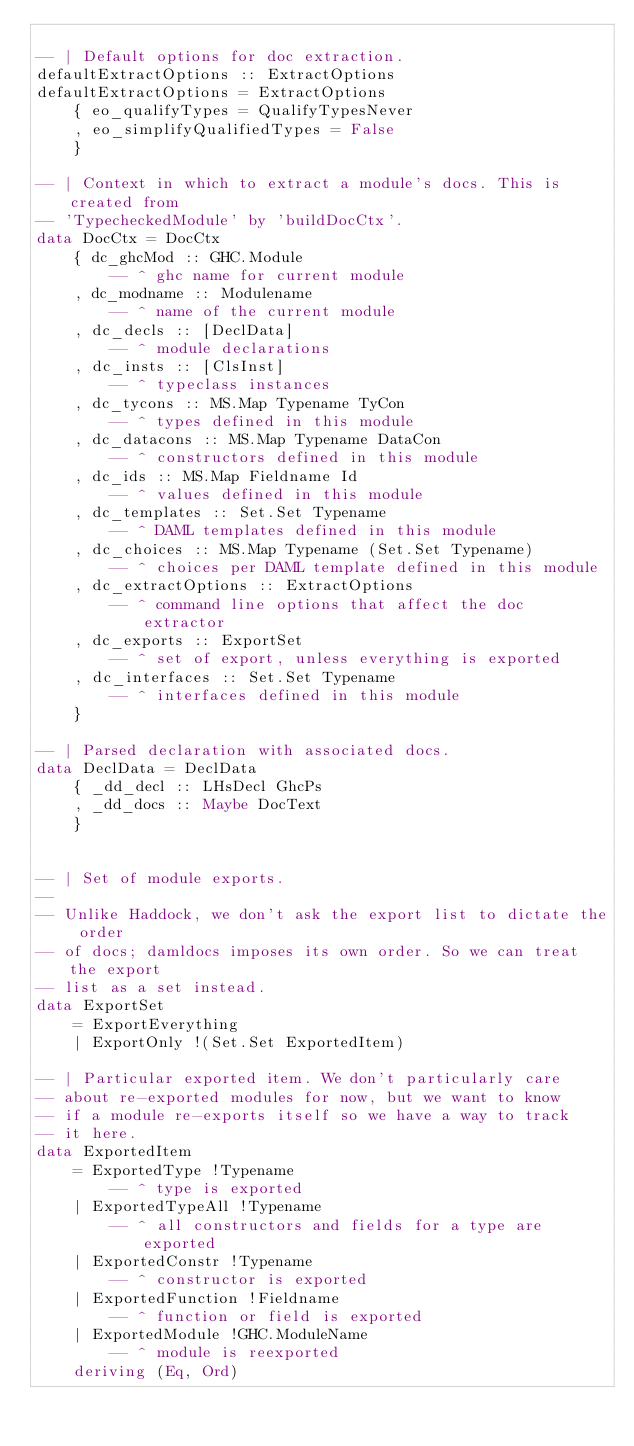Convert code to text. <code><loc_0><loc_0><loc_500><loc_500><_Haskell_>
-- | Default options for doc extraction.
defaultExtractOptions :: ExtractOptions
defaultExtractOptions = ExtractOptions
    { eo_qualifyTypes = QualifyTypesNever
    , eo_simplifyQualifiedTypes = False
    }

-- | Context in which to extract a module's docs. This is created from
-- 'TypecheckedModule' by 'buildDocCtx'.
data DocCtx = DocCtx
    { dc_ghcMod :: GHC.Module
        -- ^ ghc name for current module
    , dc_modname :: Modulename
        -- ^ name of the current module
    , dc_decls :: [DeclData]
        -- ^ module declarations
    , dc_insts :: [ClsInst]
        -- ^ typeclass instances
    , dc_tycons :: MS.Map Typename TyCon
        -- ^ types defined in this module
    , dc_datacons :: MS.Map Typename DataCon
        -- ^ constructors defined in this module
    , dc_ids :: MS.Map Fieldname Id
        -- ^ values defined in this module
    , dc_templates :: Set.Set Typename
        -- ^ DAML templates defined in this module
    , dc_choices :: MS.Map Typename (Set.Set Typename)
        -- ^ choices per DAML template defined in this module
    , dc_extractOptions :: ExtractOptions
        -- ^ command line options that affect the doc extractor
    , dc_exports :: ExportSet
        -- ^ set of export, unless everything is exported
    , dc_interfaces :: Set.Set Typename
        -- ^ interfaces defined in this module
    }

-- | Parsed declaration with associated docs.
data DeclData = DeclData
    { _dd_decl :: LHsDecl GhcPs
    , _dd_docs :: Maybe DocText
    }


-- | Set of module exports.
--
-- Unlike Haddock, we don't ask the export list to dictate the order
-- of docs; damldocs imposes its own order. So we can treat the export
-- list as a set instead.
data ExportSet
    = ExportEverything
    | ExportOnly !(Set.Set ExportedItem)

-- | Particular exported item. We don't particularly care
-- about re-exported modules for now, but we want to know
-- if a module re-exports itself so we have a way to track
-- it here.
data ExportedItem
    = ExportedType !Typename
        -- ^ type is exported
    | ExportedTypeAll !Typename
        -- ^ all constructors and fields for a type are exported
    | ExportedConstr !Typename
        -- ^ constructor is exported
    | ExportedFunction !Fieldname
        -- ^ function or field is exported
    | ExportedModule !GHC.ModuleName
        -- ^ module is reexported
    deriving (Eq, Ord)

</code> 